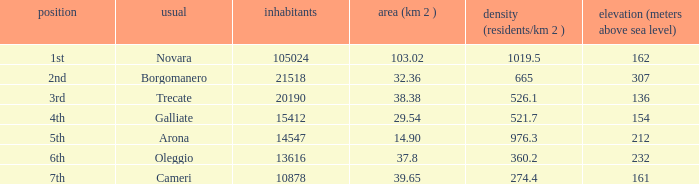Where does the common of Galliate rank in population? 4th. 